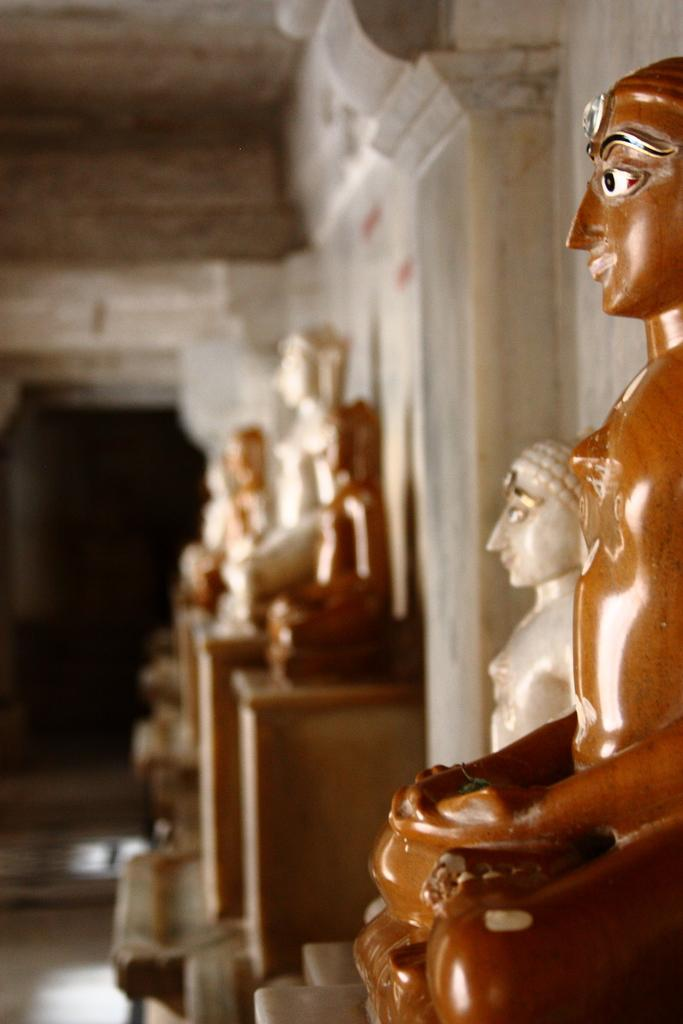What type of art is present in the image? There are sculptures in the image. What is behind the sculptures? There is a wall behind the sculptures. What part of a building can be seen at the top of the image? The roof is visible at the top of the image. What is the price of the bed in the image? There is no bed present in the image, so it is not possible to determine its price. 